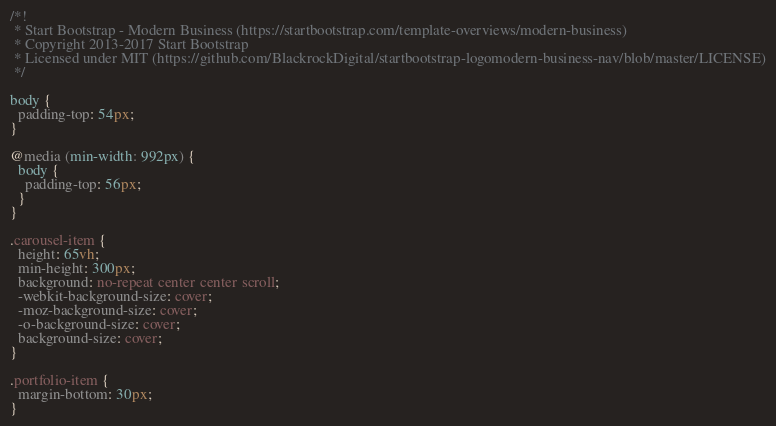Convert code to text. <code><loc_0><loc_0><loc_500><loc_500><_CSS_>/*!
 * Start Bootstrap - Modern Business (https://startbootstrap.com/template-overviews/modern-business)
 * Copyright 2013-2017 Start Bootstrap
 * Licensed under MIT (https://github.com/BlackrockDigital/startbootstrap-logomodern-business-nav/blob/master/LICENSE)
 */

body {
  padding-top: 54px;
}

@media (min-width: 992px) {
  body {
    padding-top: 56px;
  }
}

.carousel-item {
  height: 65vh;
  min-height: 300px;
  background: no-repeat center center scroll;
  -webkit-background-size: cover;
  -moz-background-size: cover;
  -o-background-size: cover;
  background-size: cover;
}

.portfolio-item {
  margin-bottom: 30px;
}
</code> 